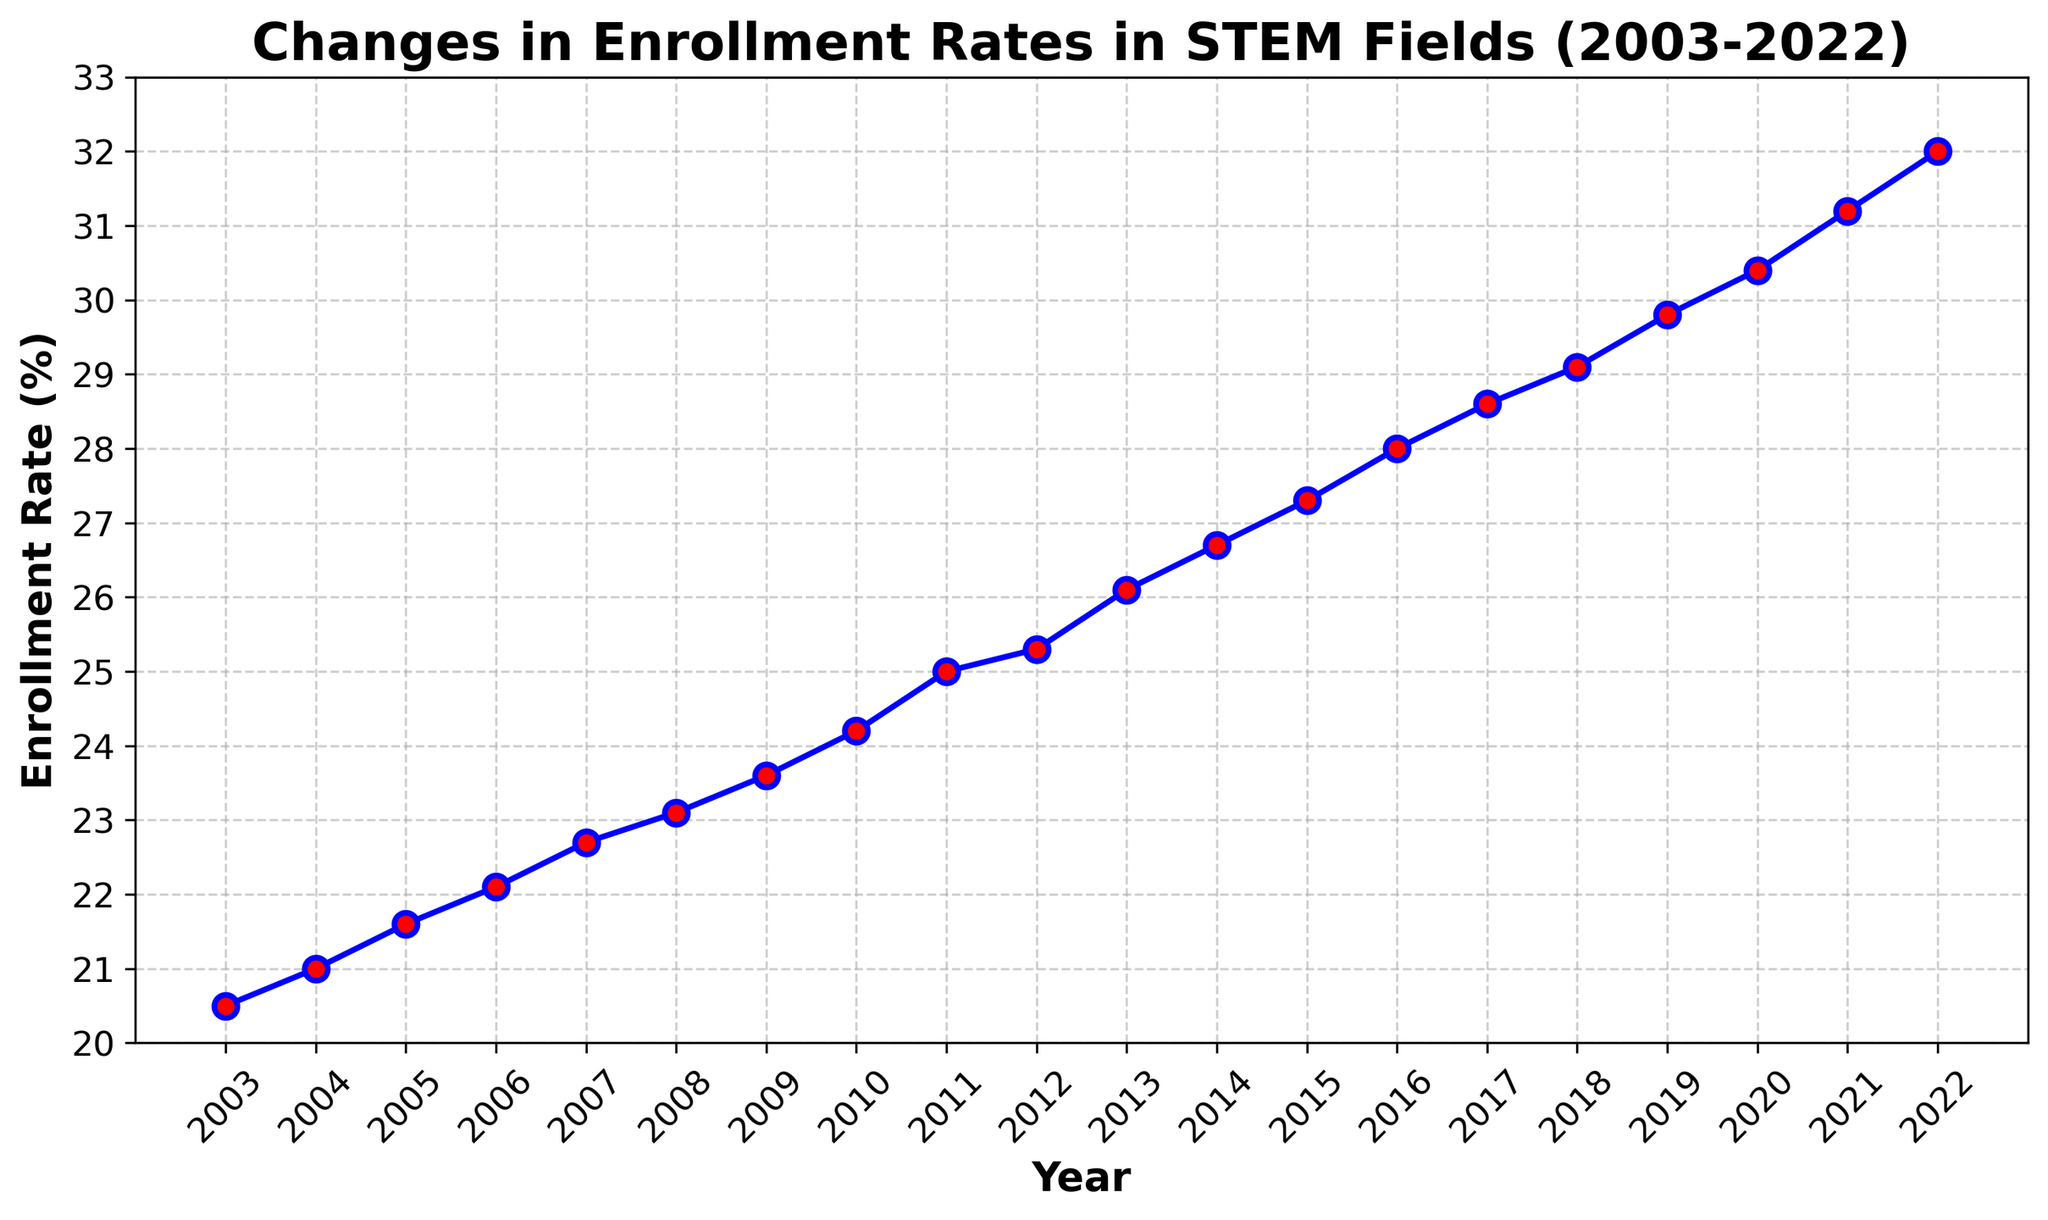What was the enrollment rate in STEM fields in 2010? The plot indicates the enrollment rate for each year. By locating the year 2010 on the x-axis, we can see that the corresponding y-value is 24.2%.
Answer: 24.2% Between which consecutive years did the enrollment rate increase the most? To find the year with the largest increase, examine the difference between each consecutive pair of years. The biggest jump appears between 2020 (30.4%) and 2021 (31.2%), an increase of 0.8%.
Answer: 2020 and 2021 What is the average enrollment rate in STEM fields from 2003 to 2022? Sum the enrollment rates from 2003 to 2022 and then divide by the number of years (20). The sum is: 20.5 + 21 + 21.6 + 22.1 + 22.7 + 23.1 + 23.6 + 24.2 + 25 + 25.3 + 26.1 + 26.7 + 27.3 + 28 + 28.6 + 29.1 + 29.8 + 30.4 + 31.2 + 32 = 475.8. Divide this by 20: 475.8 / 20 = 23.79%.
Answer: 23.79% How much did the enrollment rate increase from 2003 to 2022? Subtract the enrollment rate in 2003 (20.5%) from the enrollment rate in 2022 (32%). 32% - 20.5% = 11.5%.
Answer: 11.5% In which year did the enrollment rate first reach 25%? Look at the plotted values and find the year where the enrollment rate first equals or exceeds 25%. From the plot, this occurs in 2011.
Answer: 2011 Was the increase between 2018 and 2019 greater than the increase between 2015 and 2016? To determine this, calculate the increases: 2018 to 2019 (29.8% - 29.1%) is 0.7%, and 2015 to 2016 (28% - 27.3%) is 0.7%. Both increases are the same at 0.7%.
Answer: No What is the total increase in enrollment rate from 2003 to 2012? First, identify the enrollment rates for 2003 (20.5%) and 2012 (25.3%). Then, subtract the 2003 rate from the 2012 rate: 25.3% - 20.5% = 4.8%.
Answer: 4.8% Which color is used to mark data points in the plot? In the plot, data points are marked with red. The markers are specified to have a red face color.
Answer: Red Is the range of the y-axis labeled correctly to include all data points? The y-axis range is from 20% to 33%, which comfortably includes all data points ranging from 20.5% to 32%.
Answer: Yes 